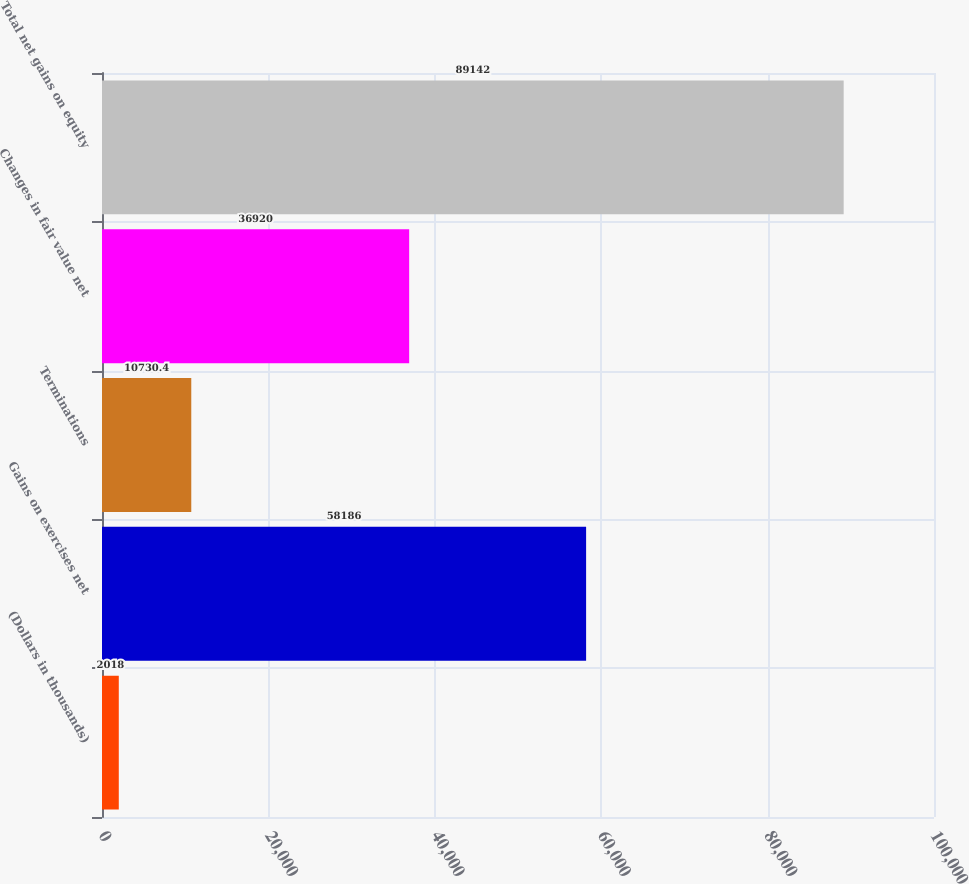Convert chart. <chart><loc_0><loc_0><loc_500><loc_500><bar_chart><fcel>(Dollars in thousands)<fcel>Gains on exercises net<fcel>Terminations<fcel>Changes in fair value net<fcel>Total net gains on equity<nl><fcel>2018<fcel>58186<fcel>10730.4<fcel>36920<fcel>89142<nl></chart> 